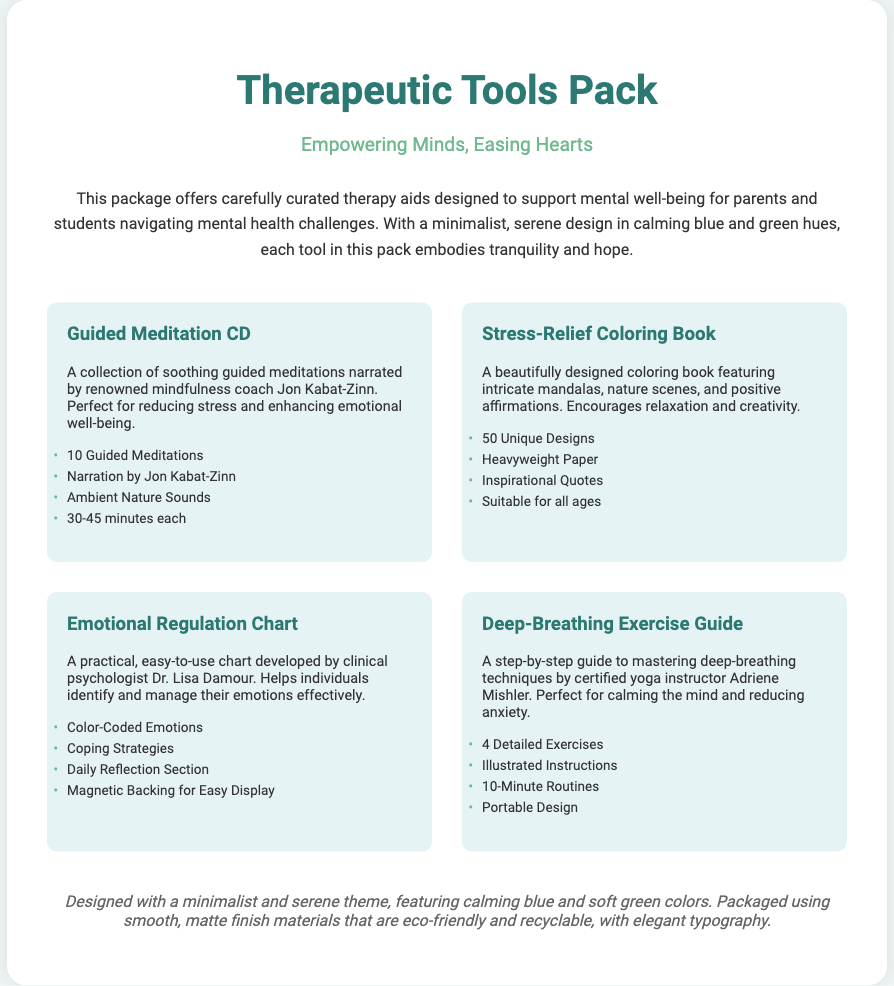What is the title of the product? The title is prominently displayed as the main heading in the document.
Answer: Therapeutic Tools Pack Who is the narration by in the Guided Meditation CD? The Guided Meditation CD lists the narrator directly in its description.
Answer: Jon Kabat-Zinn How many unique designs are in the coloring book? The number of designs is specified in the features list of the coloring book.
Answer: 50 Unique Designs What type of backing does the Emotional Regulation Chart have? The description of the chart includes information about its backing.
Answer: Magnetic Backing How many detailed exercises are included in the Deep-Breathing Exercise Guide? The guide clearly states the number of exercises it offers in its features section.
Answer: 4 Detailed Exercises What colors are featured in the design of the pack? The design colors are mentioned in the concluding description of the document.
Answer: Calming blue and soft green Who developed the Emotional Regulation Chart? The document directly attributes the chart's development to a specific person mentioned in the description.
Answer: Dr. Lisa Damour What is the purpose of the Stress-Relief Coloring Book? The description outlines the primary purpose of the coloring book succinctly.
Answer: Encourages relaxation and creativity 